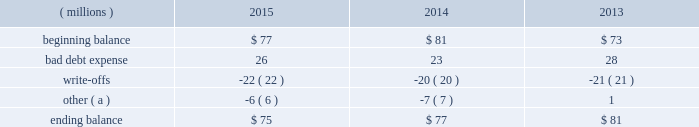Concentration of credit risk credit risk represents the accounting loss that would be recognized at the reporting date if counterparties failed to perform as contracted .
The company believes the likelihood of incurring material losses due to concentration of credit risk is remote .
The principal financial instruments subject to credit risk are as follows : cash and cash equivalents - the company maintains cash deposits with major banks , which from time to time may exceed insured limits .
The possibility of loss related to financial condition of major banks has been deemed minimal .
Additionally , the company 2019s investment policy limits exposure to concentrations of credit risk and changes in market conditions .
Accounts receivable - a large number of customers in diverse industries and geographies , as well as the practice of establishing reasonable credit lines , limits credit risk .
Based on historical trends and experiences , the allowance for doubtful accounts is adequate to cover potential credit risk losses .
Foreign currency and interest rate contracts and derivatives - exposure to credit risk is limited by internal policies and active monitoring of counterparty risks .
In addition , the company uses a diversified group of major international banks and financial institutions as counterparties .
The company does not anticipate nonperformance by any of these counterparties .
Cash and cash equivalents cash equivalents include highly-liquid investments with a maturity of three months or less when purchased .
Accounts receivable and allowance for doubtful accounts accounts receivable are carried at their face amounts less an allowance for doubtful accounts .
Accounts receivable are recorded at the invoiced amount and generally do not bear interest .
The company estimates the balance of allowance for doubtful accounts by analyzing accounts receivable balances by age and applying historical write-off and collection trend rates .
The company 2019s estimates include separately providing for customer balances based on specific circumstances and credit conditions , and when it is deemed probable that the balance is uncollectible .
Account balances are charged off against the allowance when it is determined the receivable will not be recovered .
The company 2019s allowance for doubtful accounts balance also includes an allowance for the expected return of products shipped and credits related to pricing or quantities shipped of $ 15 million as of december 31 , 2015 and 2014 and $ 14 million as of december 31 , 2013 .
Returns and credit activity is recorded directly to sales .
The table summarizes the activity in the allowance for doubtful accounts: .
( a ) other amounts are primarily the effects of changes in currency translations and the impact of allowance for returns and credits .
Inventory valuations inventories are valued at the lower of cost or market .
Certain u.s .
Inventory costs are determined on a last-in , first-out ( lifo ) basis .
Lifo inventories represented 39% ( 39 % ) and 37% ( 37 % ) of consolidated inventories as of december 31 , 2015 and 2014 , respectively .
Lifo inventories include certain legacy nalco u.s .
Inventory acquired at fair value as part of the nalco merger .
All other inventory costs are determined using either the average cost or first-in , first-out ( fifo ) methods .
Inventory values at fifo , as shown in note 5 , approximate replacement during the fourth quarter of 2015 , the company improved estimates related to its inventory reserves and product costing , resulting in a net pre-tax charge of approximately $ 6 million .
Separately , the actions resulted in charge of $ 20.6 million related to inventory reserve calculations , partially offset by a gain of $ 14.5 million related to the capitalization of certain cost components into inventory .
Both of these items are reflected in note 3. .
What is the net change in the balance of allowance for doubtful accounts during 2015? 
Computations: ((26 + -22) + -6)
Answer: -2.0. Concentration of credit risk credit risk represents the accounting loss that would be recognized at the reporting date if counterparties failed to perform as contracted .
The company believes the likelihood of incurring material losses due to concentration of credit risk is remote .
The principal financial instruments subject to credit risk are as follows : cash and cash equivalents - the company maintains cash deposits with major banks , which from time to time may exceed insured limits .
The possibility of loss related to financial condition of major banks has been deemed minimal .
Additionally , the company 2019s investment policy limits exposure to concentrations of credit risk and changes in market conditions .
Accounts receivable - a large number of customers in diverse industries and geographies , as well as the practice of establishing reasonable credit lines , limits credit risk .
Based on historical trends and experiences , the allowance for doubtful accounts is adequate to cover potential credit risk losses .
Foreign currency and interest rate contracts and derivatives - exposure to credit risk is limited by internal policies and active monitoring of counterparty risks .
In addition , the company uses a diversified group of major international banks and financial institutions as counterparties .
The company does not anticipate nonperformance by any of these counterparties .
Cash and cash equivalents cash equivalents include highly-liquid investments with a maturity of three months or less when purchased .
Accounts receivable and allowance for doubtful accounts accounts receivable are carried at their face amounts less an allowance for doubtful accounts .
Accounts receivable are recorded at the invoiced amount and generally do not bear interest .
The company estimates the balance of allowance for doubtful accounts by analyzing accounts receivable balances by age and applying historical write-off and collection trend rates .
The company 2019s estimates include separately providing for customer balances based on specific circumstances and credit conditions , and when it is deemed probable that the balance is uncollectible .
Account balances are charged off against the allowance when it is determined the receivable will not be recovered .
The company 2019s allowance for doubtful accounts balance also includes an allowance for the expected return of products shipped and credits related to pricing or quantities shipped of $ 15 million as of december 31 , 2015 and 2014 and $ 14 million as of december 31 , 2013 .
Returns and credit activity is recorded directly to sales .
The table summarizes the activity in the allowance for doubtful accounts: .
( a ) other amounts are primarily the effects of changes in currency translations and the impact of allowance for returns and credits .
Inventory valuations inventories are valued at the lower of cost or market .
Certain u.s .
Inventory costs are determined on a last-in , first-out ( lifo ) basis .
Lifo inventories represented 39% ( 39 % ) and 37% ( 37 % ) of consolidated inventories as of december 31 , 2015 and 2014 , respectively .
Lifo inventories include certain legacy nalco u.s .
Inventory acquired at fair value as part of the nalco merger .
All other inventory costs are determined using either the average cost or first-in , first-out ( fifo ) methods .
Inventory values at fifo , as shown in note 5 , approximate replacement during the fourth quarter of 2015 , the company improved estimates related to its inventory reserves and product costing , resulting in a net pre-tax charge of approximately $ 6 million .
Separately , the actions resulted in charge of $ 20.6 million related to inventory reserve calculations , partially offset by a gain of $ 14.5 million related to the capitalization of certain cost components into inventory .
Both of these items are reflected in note 3. .
What is the growth rate in the balance of allowance for doubtful accounts from 2014 to 2015? 
Computations: ((75 - 77) + 77)
Answer: 75.0. 